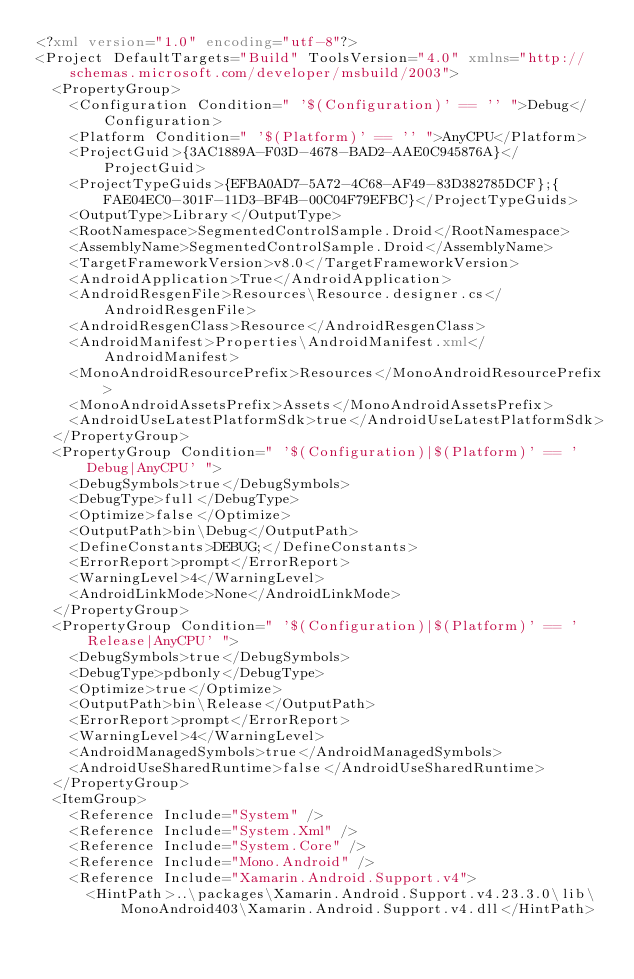Convert code to text. <code><loc_0><loc_0><loc_500><loc_500><_XML_><?xml version="1.0" encoding="utf-8"?>
<Project DefaultTargets="Build" ToolsVersion="4.0" xmlns="http://schemas.microsoft.com/developer/msbuild/2003">
  <PropertyGroup>
    <Configuration Condition=" '$(Configuration)' == '' ">Debug</Configuration>
    <Platform Condition=" '$(Platform)' == '' ">AnyCPU</Platform>
    <ProjectGuid>{3AC1889A-F03D-4678-BAD2-AAE0C945876A}</ProjectGuid>
    <ProjectTypeGuids>{EFBA0AD7-5A72-4C68-AF49-83D382785DCF};{FAE04EC0-301F-11D3-BF4B-00C04F79EFBC}</ProjectTypeGuids>
    <OutputType>Library</OutputType>
    <RootNamespace>SegmentedControlSample.Droid</RootNamespace>
    <AssemblyName>SegmentedControlSample.Droid</AssemblyName>
    <TargetFrameworkVersion>v8.0</TargetFrameworkVersion>
    <AndroidApplication>True</AndroidApplication>
    <AndroidResgenFile>Resources\Resource.designer.cs</AndroidResgenFile>
    <AndroidResgenClass>Resource</AndroidResgenClass>
    <AndroidManifest>Properties\AndroidManifest.xml</AndroidManifest>
    <MonoAndroidResourcePrefix>Resources</MonoAndroidResourcePrefix>
    <MonoAndroidAssetsPrefix>Assets</MonoAndroidAssetsPrefix>
    <AndroidUseLatestPlatformSdk>true</AndroidUseLatestPlatformSdk>
  </PropertyGroup>
  <PropertyGroup Condition=" '$(Configuration)|$(Platform)' == 'Debug|AnyCPU' ">
    <DebugSymbols>true</DebugSymbols>
    <DebugType>full</DebugType>
    <Optimize>false</Optimize>
    <OutputPath>bin\Debug</OutputPath>
    <DefineConstants>DEBUG;</DefineConstants>
    <ErrorReport>prompt</ErrorReport>
    <WarningLevel>4</WarningLevel>
    <AndroidLinkMode>None</AndroidLinkMode>
  </PropertyGroup>
  <PropertyGroup Condition=" '$(Configuration)|$(Platform)' == 'Release|AnyCPU' ">
    <DebugSymbols>true</DebugSymbols>
    <DebugType>pdbonly</DebugType>
    <Optimize>true</Optimize>
    <OutputPath>bin\Release</OutputPath>
    <ErrorReport>prompt</ErrorReport>
    <WarningLevel>4</WarningLevel>
    <AndroidManagedSymbols>true</AndroidManagedSymbols>
    <AndroidUseSharedRuntime>false</AndroidUseSharedRuntime>
  </PropertyGroup>
  <ItemGroup>
    <Reference Include="System" />
    <Reference Include="System.Xml" />
    <Reference Include="System.Core" />
    <Reference Include="Mono.Android" />
    <Reference Include="Xamarin.Android.Support.v4">
      <HintPath>..\packages\Xamarin.Android.Support.v4.23.3.0\lib\MonoAndroid403\Xamarin.Android.Support.v4.dll</HintPath></code> 